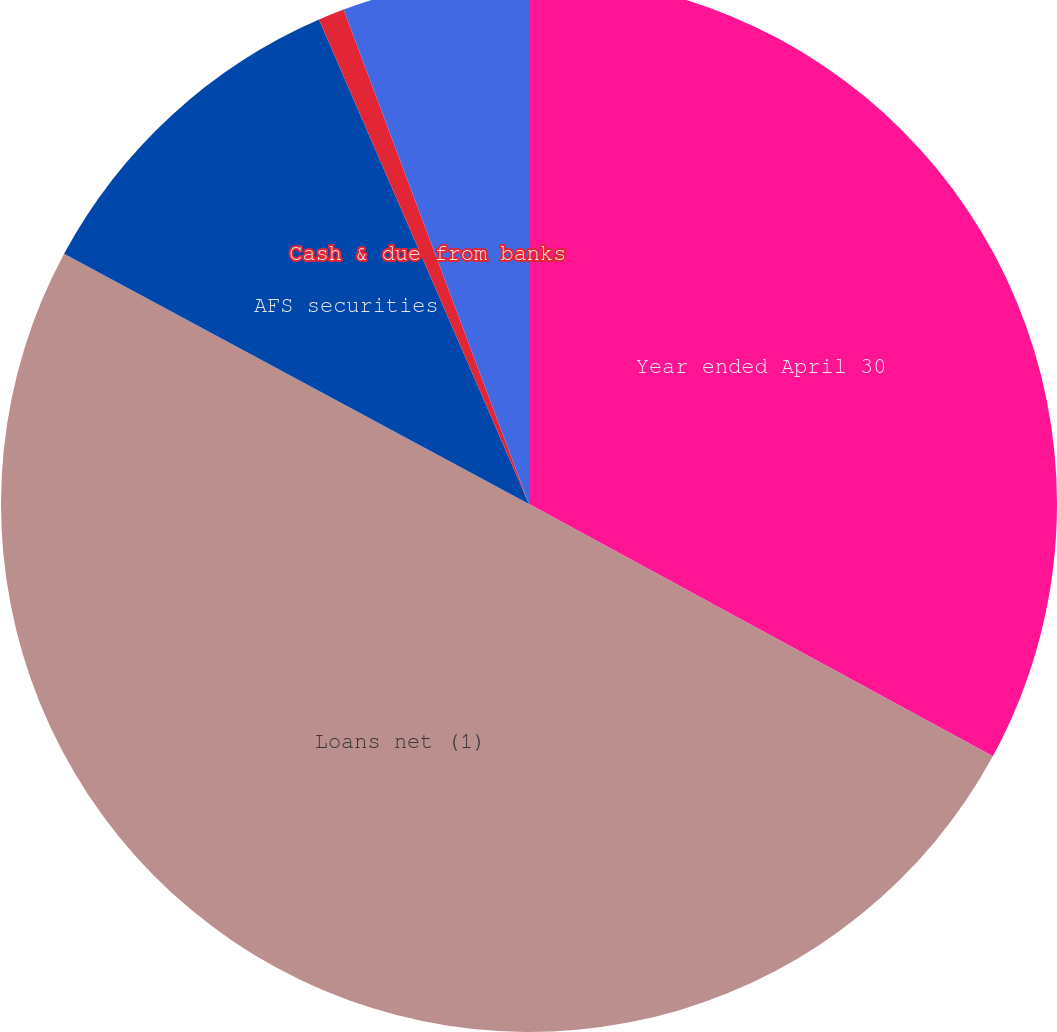Convert chart to OTSL. <chart><loc_0><loc_0><loc_500><loc_500><pie_chart><fcel>Year ended April 30<fcel>Loans net (1)<fcel>AFS securities<fcel>Cash & due from banks<fcel>Customer deposits<nl><fcel>32.93%<fcel>49.93%<fcel>10.63%<fcel>0.8%<fcel>5.71%<nl></chart> 